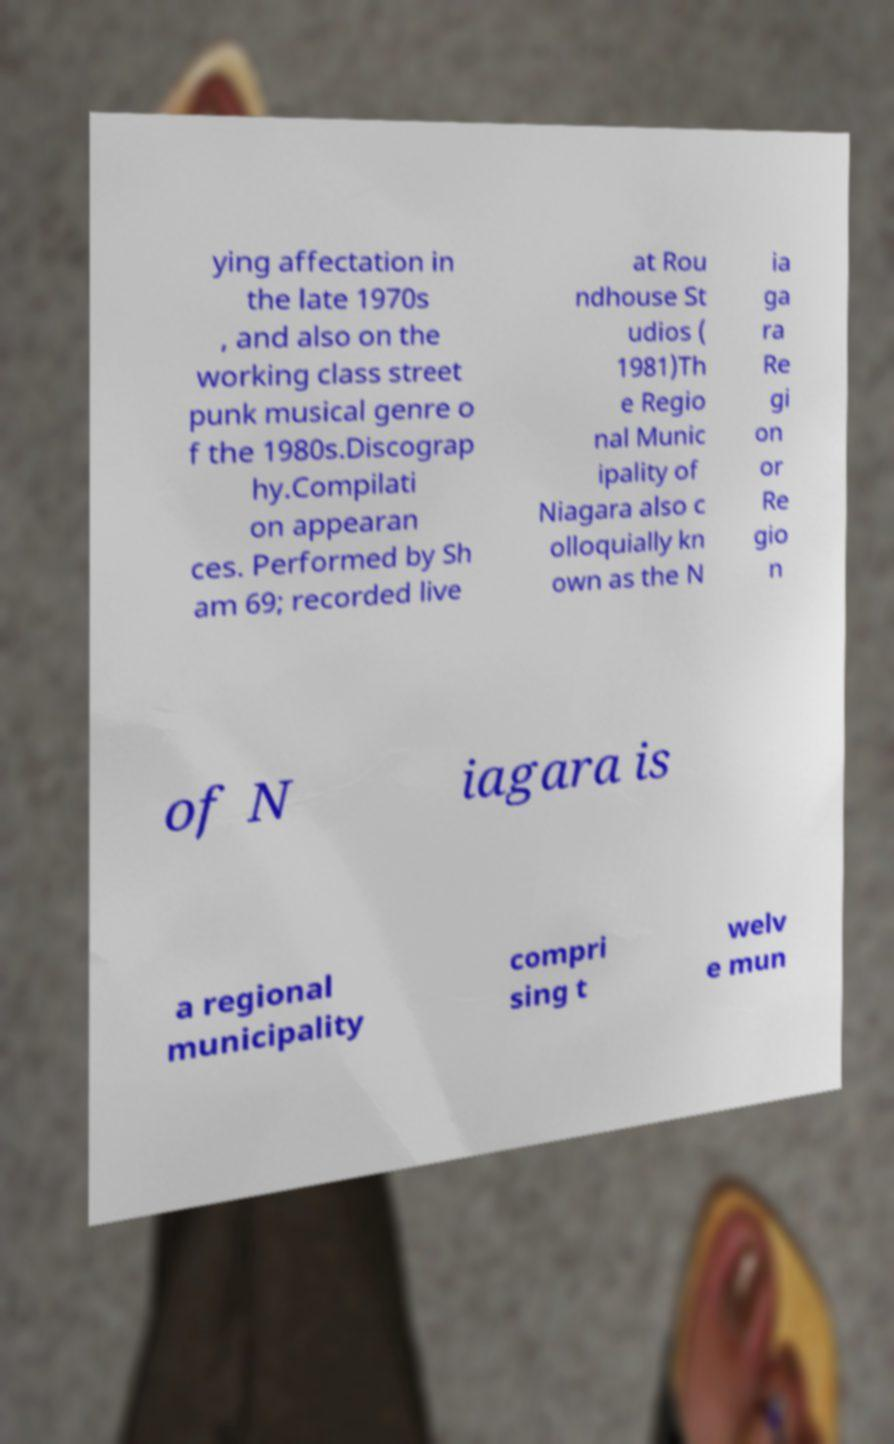What messages or text are displayed in this image? I need them in a readable, typed format. ying affectation in the late 1970s , and also on the working class street punk musical genre o f the 1980s.Discograp hy.Compilati on appearan ces. Performed by Sh am 69; recorded live at Rou ndhouse St udios ( 1981)Th e Regio nal Munic ipality of Niagara also c olloquially kn own as the N ia ga ra Re gi on or Re gio n of N iagara is a regional municipality compri sing t welv e mun 